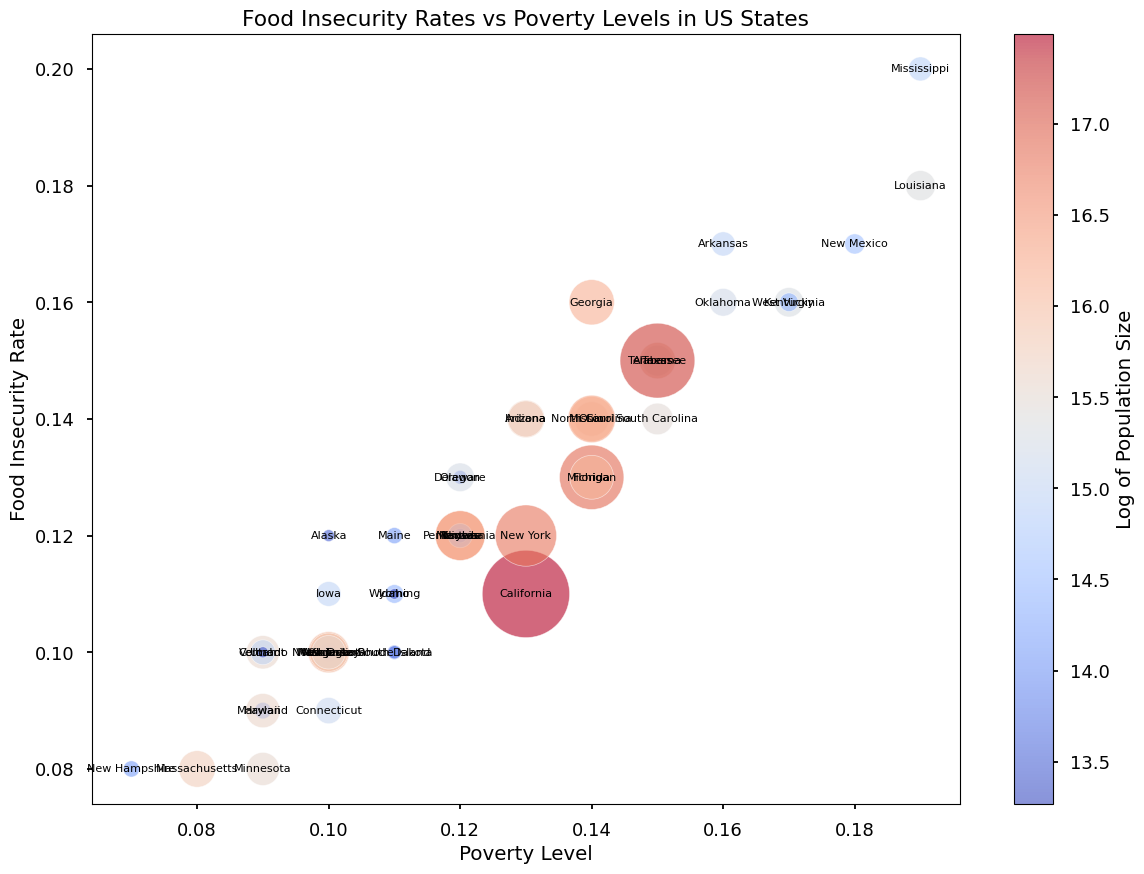What state has the highest food insecurity rate? By examining the y-axis (Food Insecurity Rate) and identifying the state with the highest point, we notice that Mississippi has the highest food insecurity rate at 0.20.
Answer: Mississippi Which state has the lowest poverty level? By examining the x-axis (Poverty Level) and locating the state with the lowest point, we see that New Hampshire has the lowest poverty level at 0.07.
Answer: New Hampshire How does the population size of California compare to that of Texas? By comparing the bubble sizes representing California and Texas, it is clear that California, with a much larger bubble, has a greater population size than Texas.
Answer: California has a greater population size Which state has the highest combination of food insecurity rate and poverty level? By examining the upper right section of the plot where both the food insecurity rate and poverty level are high, Louisiana stands out with high values in both categories.
Answer: Louisiana Is there a positive correlation between poverty level and food insecurity rate among the states? By observing the general trend of the scatter plot, we can see that as the poverty level increases (moves to the right on the x-axis), the food insecurity rate tends to increase (moves up on the y-axis), indicating a positive correlation.
Answer: Yes What is the color of the bubble representing the state of Florida, and what does it indicate about its population size? The bubble of Florida is colored in a warmer color (closer to red), indicating that Florida has a relatively large population size. The color bar shows that warm colors indicate higher logarithmic values of population size.
Answer: Warmer color, large population size Are there any states with a low food insecurity rate but medium to high poverty levels? By looking at the lower part of the scatter plot (low food insecurity rate) and checking for medium to high values on the x-axis (poverty level), we see that no states have such a combination.
Answer: No Which states have similar food insecurity and poverty levels to Texas? By comparing bubbles near Texas' bubble, we identify that Alabama and Tennessee have very similar food insecurity rates (around 0.15) and poverty levels (around 0.15).
Answer: Alabama and Tennessee How do the states of Iowa and Wisconsin compare in terms of food insecurity rates and poverty levels? Iowa has a poverty level of 0.10 and a food insecurity rate of 0.11, while Wisconsin has both values at 0.10. This makes Wisconsin slightly better in food insecurity rate but equal in poverty levels.
Answer: Iowa has a slightly higher food insecurity rate What's the average food insecurity rate for states with a poverty level of 0.12? To calculate this, we identify the states with a 0.12 poverty level (Alaska, Illinois, Kansas, Montana, Nevada, Oregon, Pennsylvania) and average their food insecurity rates, which are 0.12, 0.12, 0.12, 0.12, 0.12, 0.12, 0.13, respectively. The sum is 0.85, and the average is 0.85/7 ≈ 0.121
Answer: 0.121 